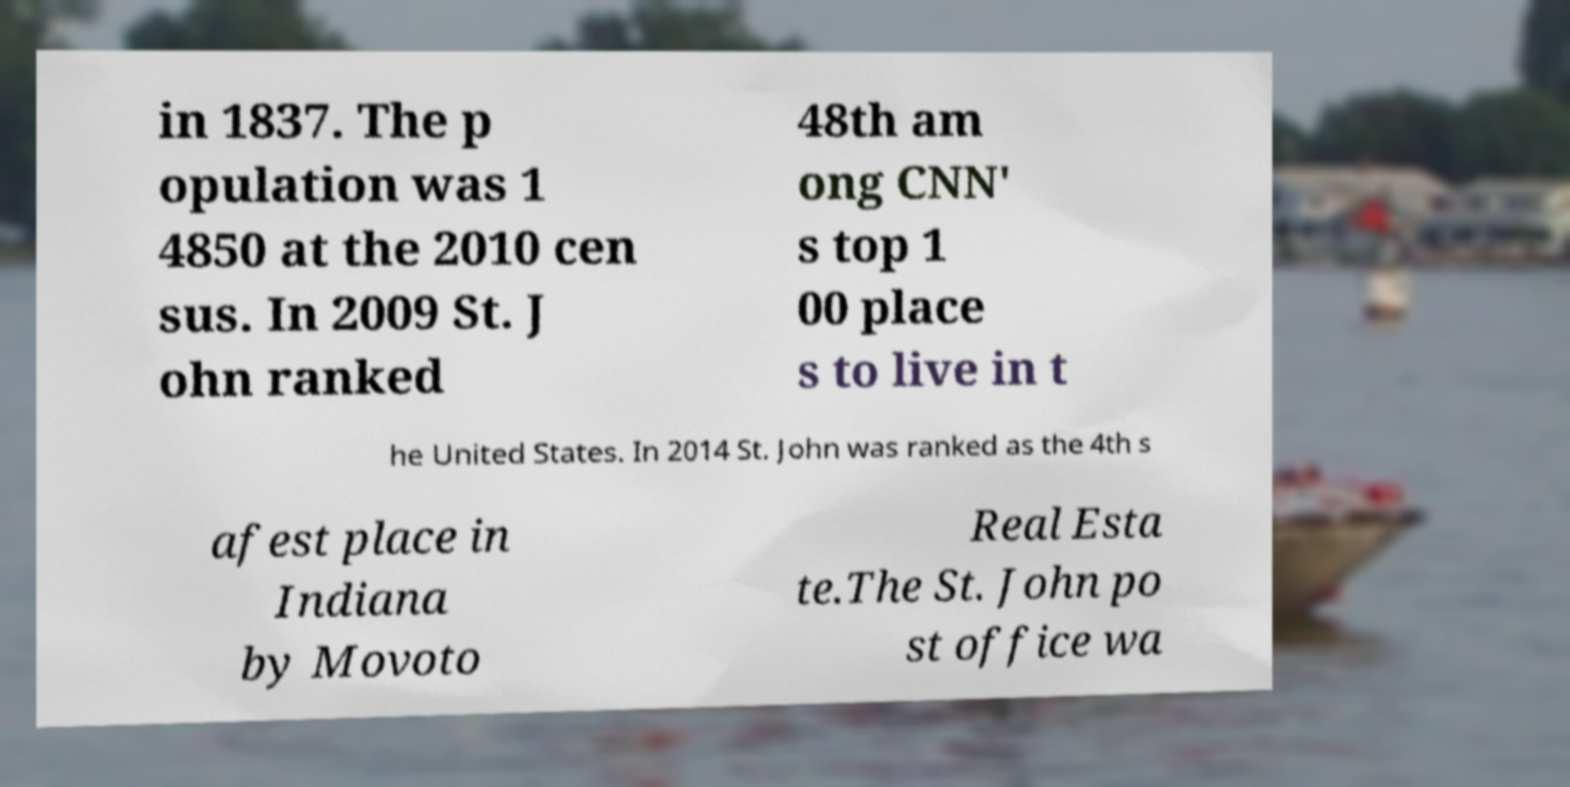Please read and relay the text visible in this image. What does it say? in 1837. The p opulation was 1 4850 at the 2010 cen sus. In 2009 St. J ohn ranked 48th am ong CNN' s top 1 00 place s to live in t he United States. In 2014 St. John was ranked as the 4th s afest place in Indiana by Movoto Real Esta te.The St. John po st office wa 